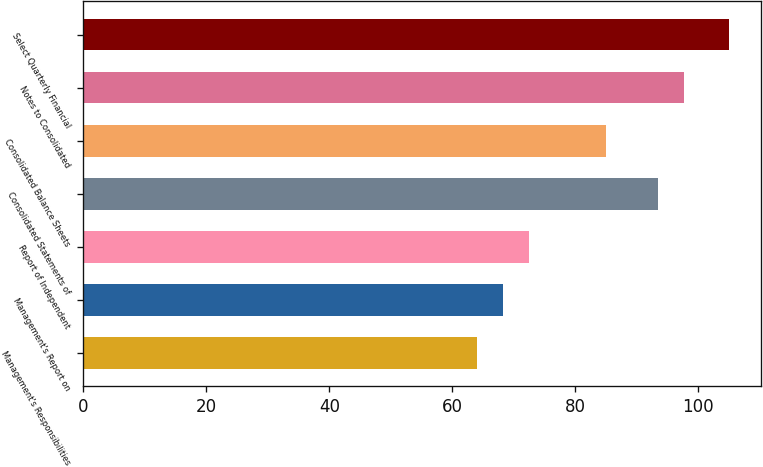Convert chart. <chart><loc_0><loc_0><loc_500><loc_500><bar_chart><fcel>Management's Responsibilities<fcel>Management's Report on<fcel>Report of Independent<fcel>Consolidated Statements of<fcel>Consolidated Balance Sheets<fcel>Notes to Consolidated<fcel>Select Quarterly Financial<nl><fcel>64<fcel>68.2<fcel>72.4<fcel>93.4<fcel>85<fcel>97.6<fcel>105<nl></chart> 